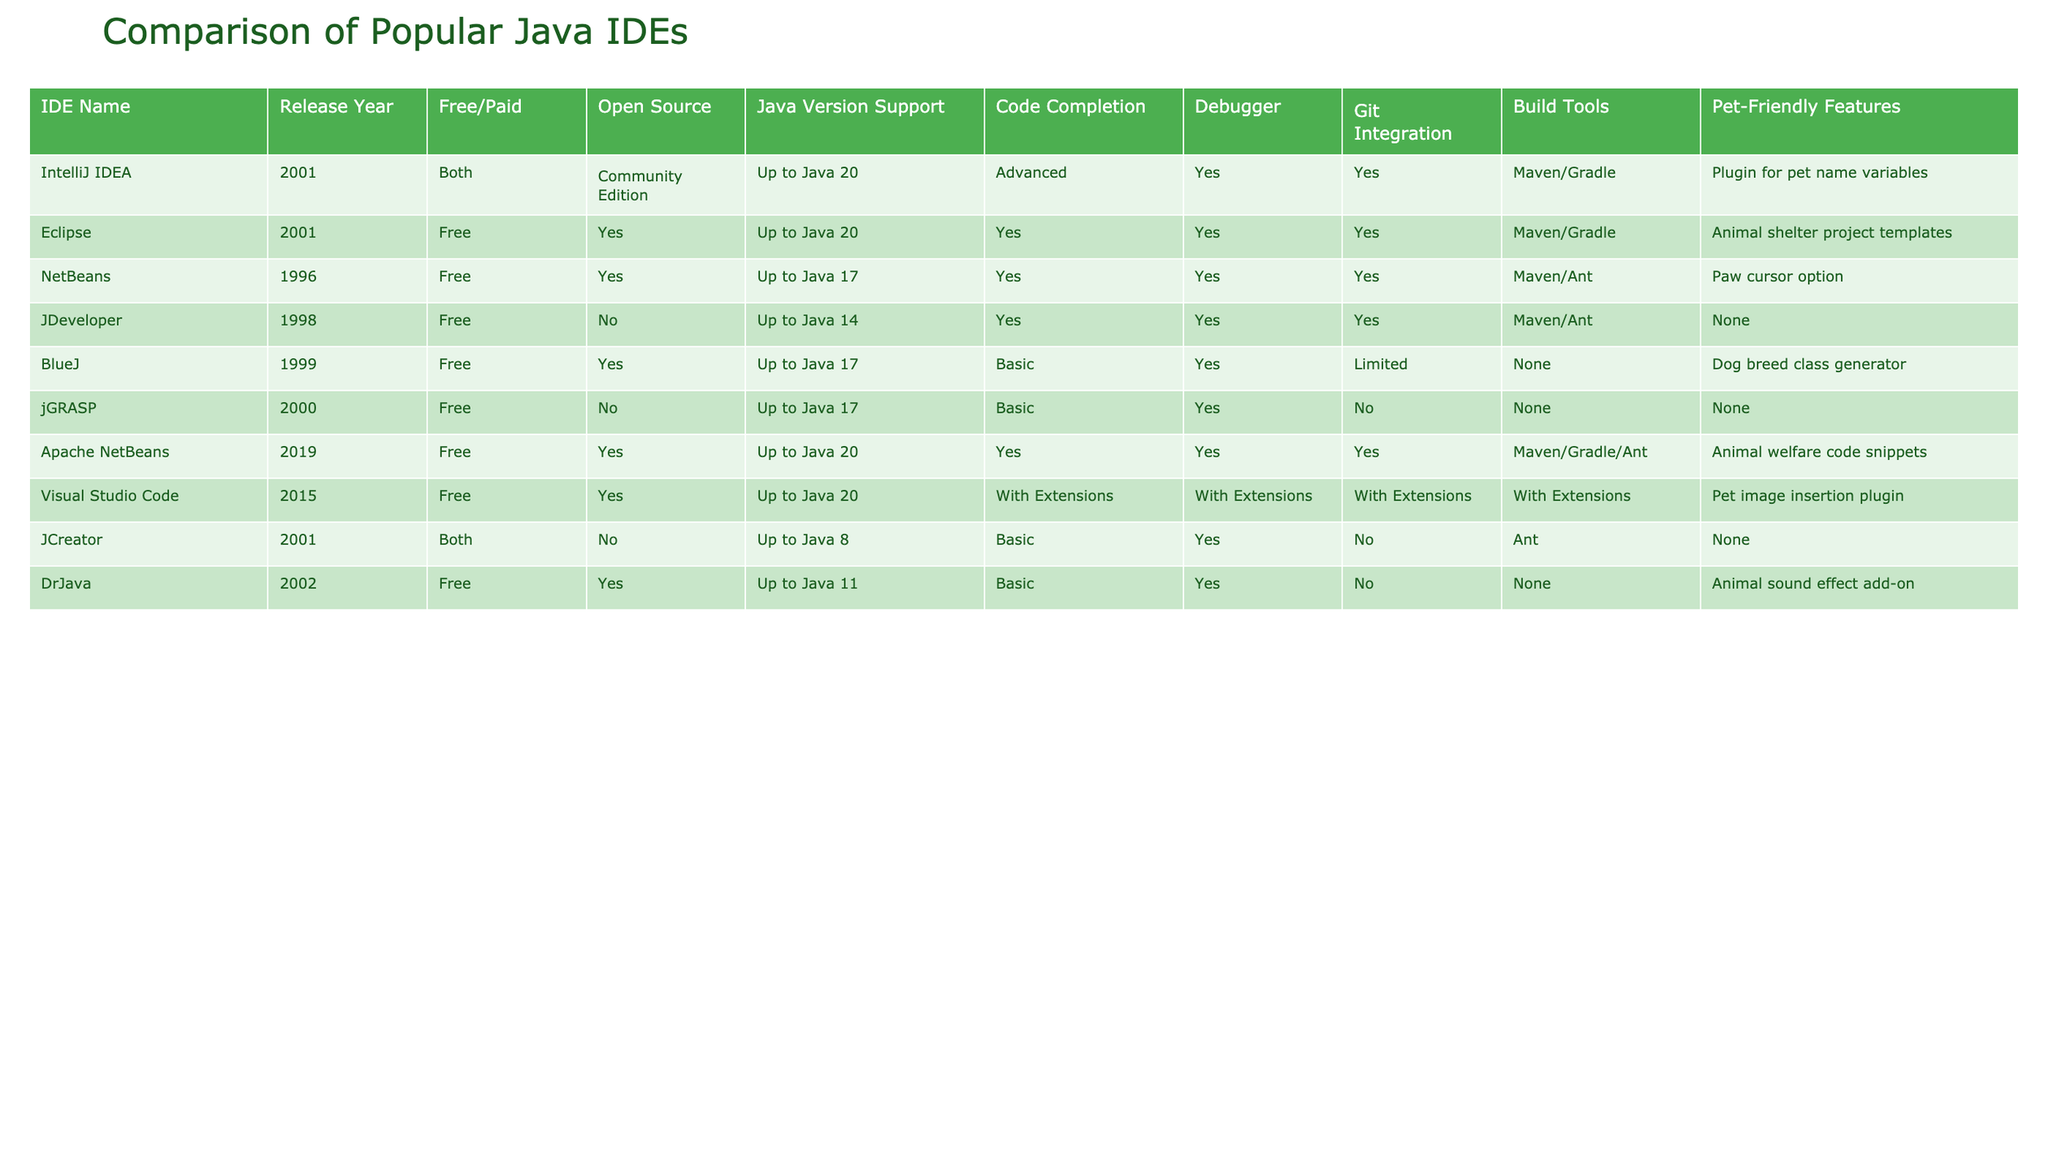What is the release year of IntelliJ IDEA? The table indicates that the release year for IntelliJ IDEA is 2001.
Answer: 2001 Which IDE supports the highest version of Java? Both IntelliJ IDEA and Visual Studio Code support up to Java 20, which is the highest version listed in the table.
Answer: IntelliJ IDEA and Visual Studio Code Is Eclipse an open-source IDE? According to the table, Eclipse is marked as "Yes" for open source.
Answer: Yes How many IDEs in the table support Git integration? By scanning the Git Integration column, I find that six IDEs support Git integration: IntelliJ IDEA, Eclipse, NetBeans, JDeveloper, Apache NetBeans, and Visual Studio Code.
Answer: 6 Which IDE has pet-friendly features that include animal shelter project templates? The table shows that Eclipse has pet-friendly features that include animal shelter project templates.
Answer: Eclipse What is the difference in Java version support between JCreator and DrJava? JCreator supports up to Java 8 while DrJava supports up to Java 11, so the difference is 3 versions (11 - 8 = 3).
Answer: 3 Which IDEs are free and offer advanced code completion? Only IntelliJ IDEA and Eclipse offer advanced code completion, both of which are free IDEs listed in the table.
Answer: IntelliJ IDEA and Eclipse How many IDEs provide both free and paid options? Referring to the Free/Paid column, I observe that two IDEs, IntelliJ IDEA and JCreator, offer both free and paid options.
Answer: 2 Is Visual Studio Code suitable for Java version support up to 17? The table indicates that Visual Studio Code supports Java versions up to 20, thereby also supporting versions up to 17.
Answer: Yes Which IDE has the least Java version support and what is that version? The IDE with the least Java version support is JCreator, which supports up to Java 8.
Answer: JCreator, Java 8 